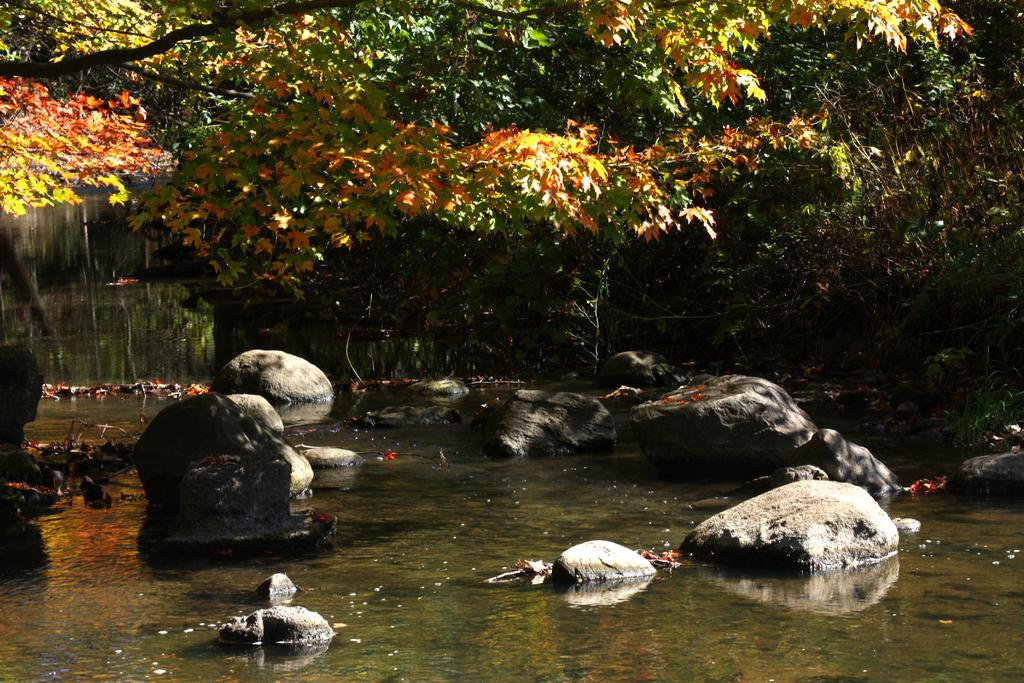What type of natural elements can be seen in the image? There are stones and leaves on the water visible in the image. What can be seen in the background of the image? There are trees visible in the background of the image. What type of wool can be seen in the image? There is no wool present in the image; it features stones, leaves on the water, and trees in the background. 